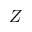Convert formula to latex. <formula><loc_0><loc_0><loc_500><loc_500>Z</formula> 